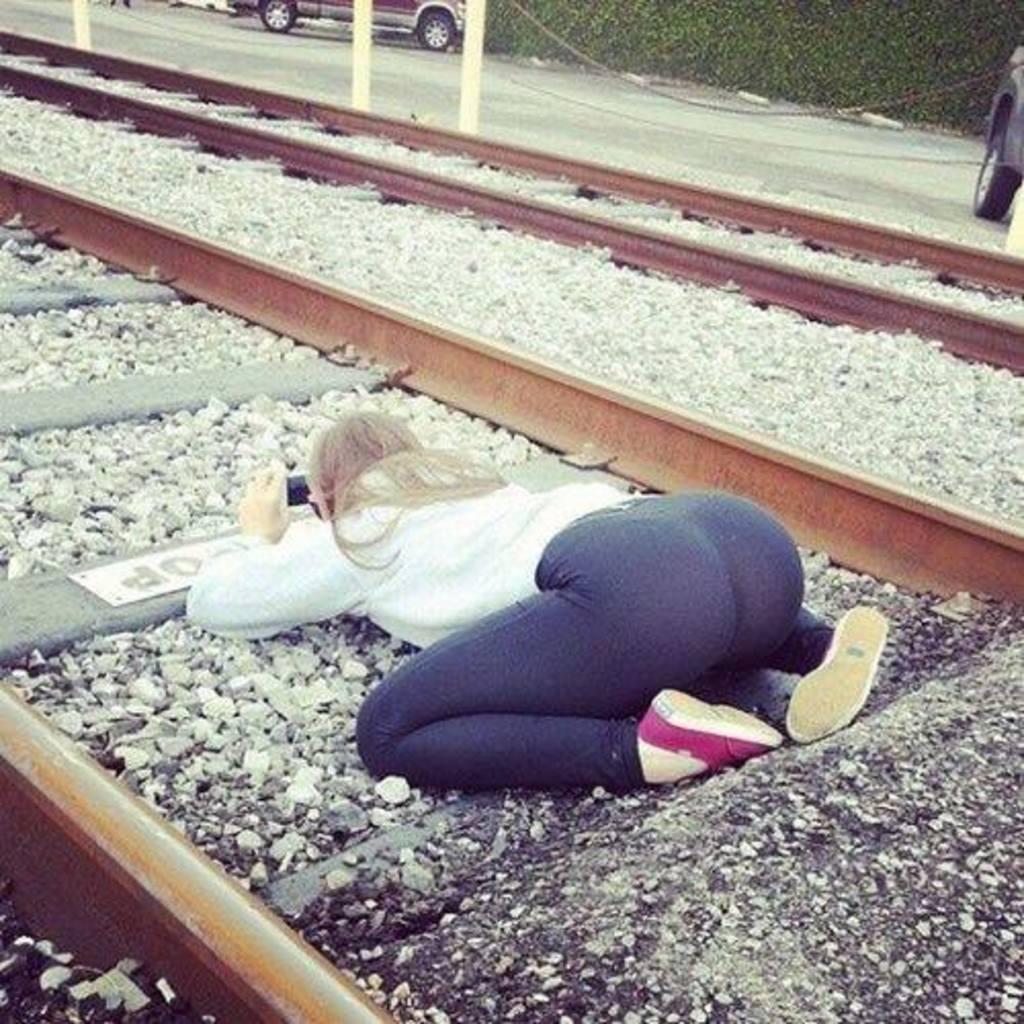Describe this image in one or two sentences. In this picture there is a woman sitting on the railway track and holding the device. At the back there are vehicles on the road and there are poles. At the bottom there are railway tracks and stones. 